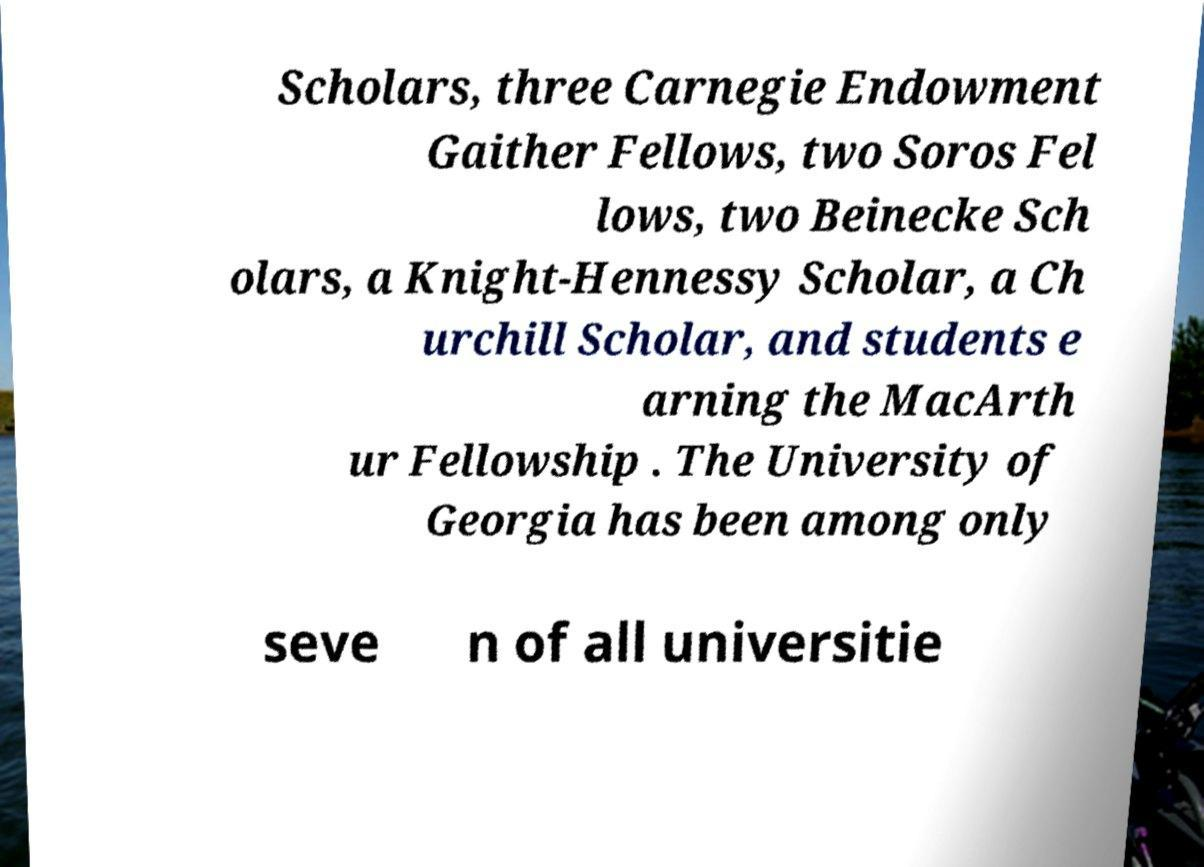Can you read and provide the text displayed in the image?This photo seems to have some interesting text. Can you extract and type it out for me? Scholars, three Carnegie Endowment Gaither Fellows, two Soros Fel lows, two Beinecke Sch olars, a Knight-Hennessy Scholar, a Ch urchill Scholar, and students e arning the MacArth ur Fellowship . The University of Georgia has been among only seve n of all universitie 